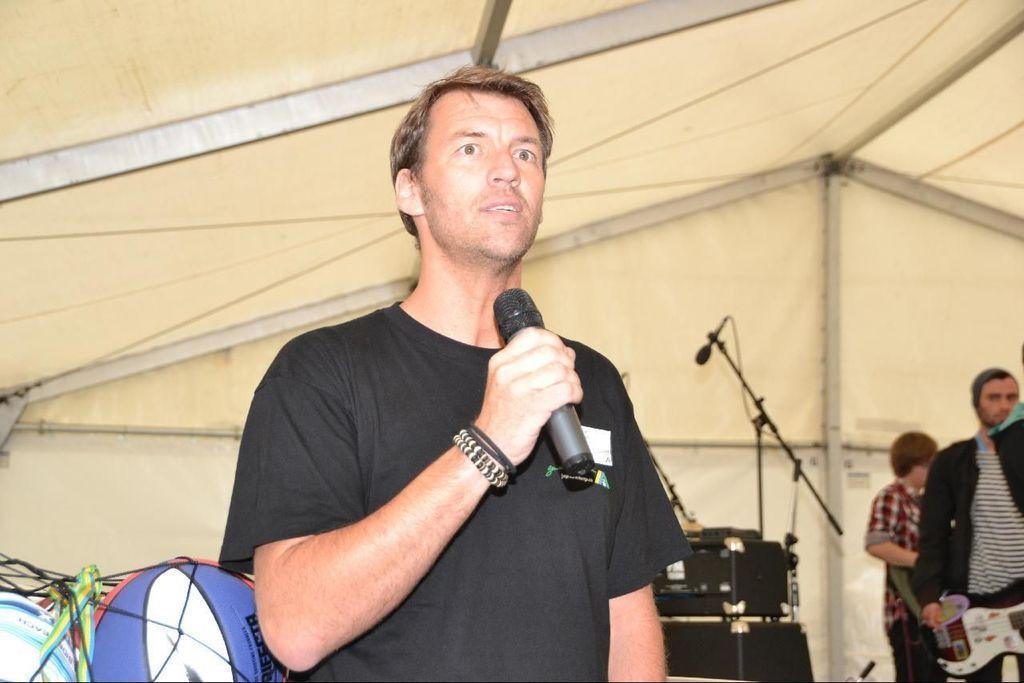How would you summarize this image in a sentence or two? There is a person standing in the center. He is holding a microphone in his hand and he is speaking. Here we can see two persons on the right side. 